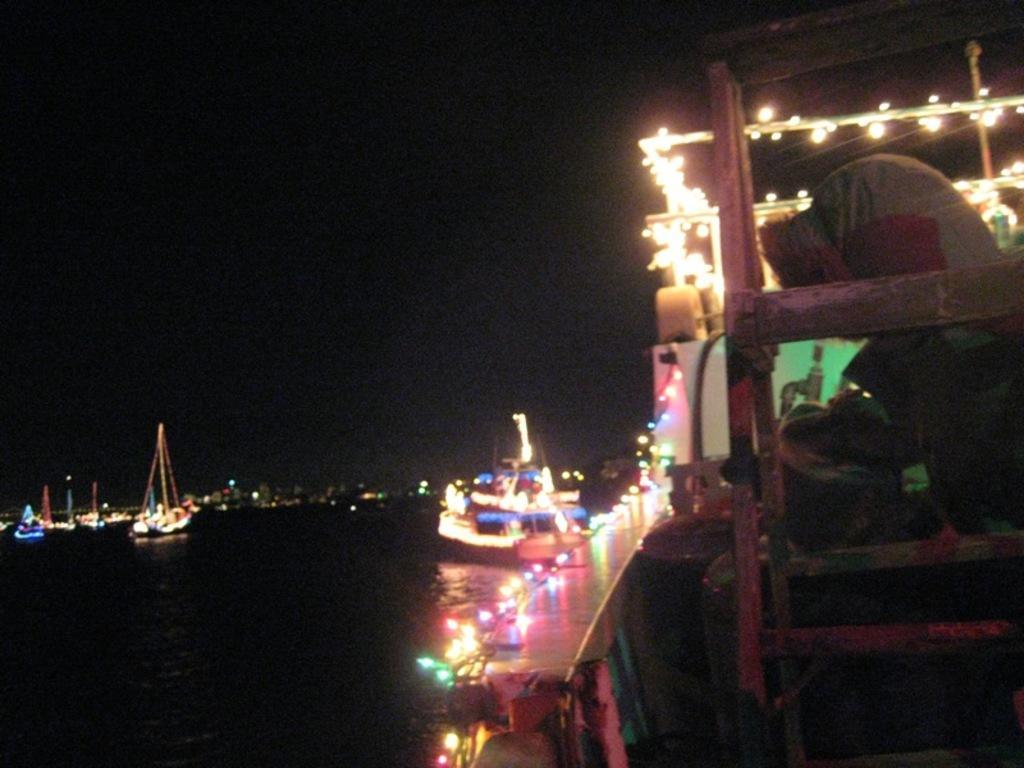In one or two sentences, can you explain what this image depicts? This image consists of ships and boats. To the right, there is a person. At the bottom, there is water. At the top, there is a sky. 